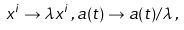<formula> <loc_0><loc_0><loc_500><loc_500>x ^ { i } \rightarrow \lambda x ^ { i } \, , a ( t ) \rightarrow a ( t ) / \lambda \, ,</formula> 